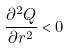Convert formula to latex. <formula><loc_0><loc_0><loc_500><loc_500>\frac { \partial ^ { 2 } Q } { \partial r ^ { 2 } } < 0</formula> 